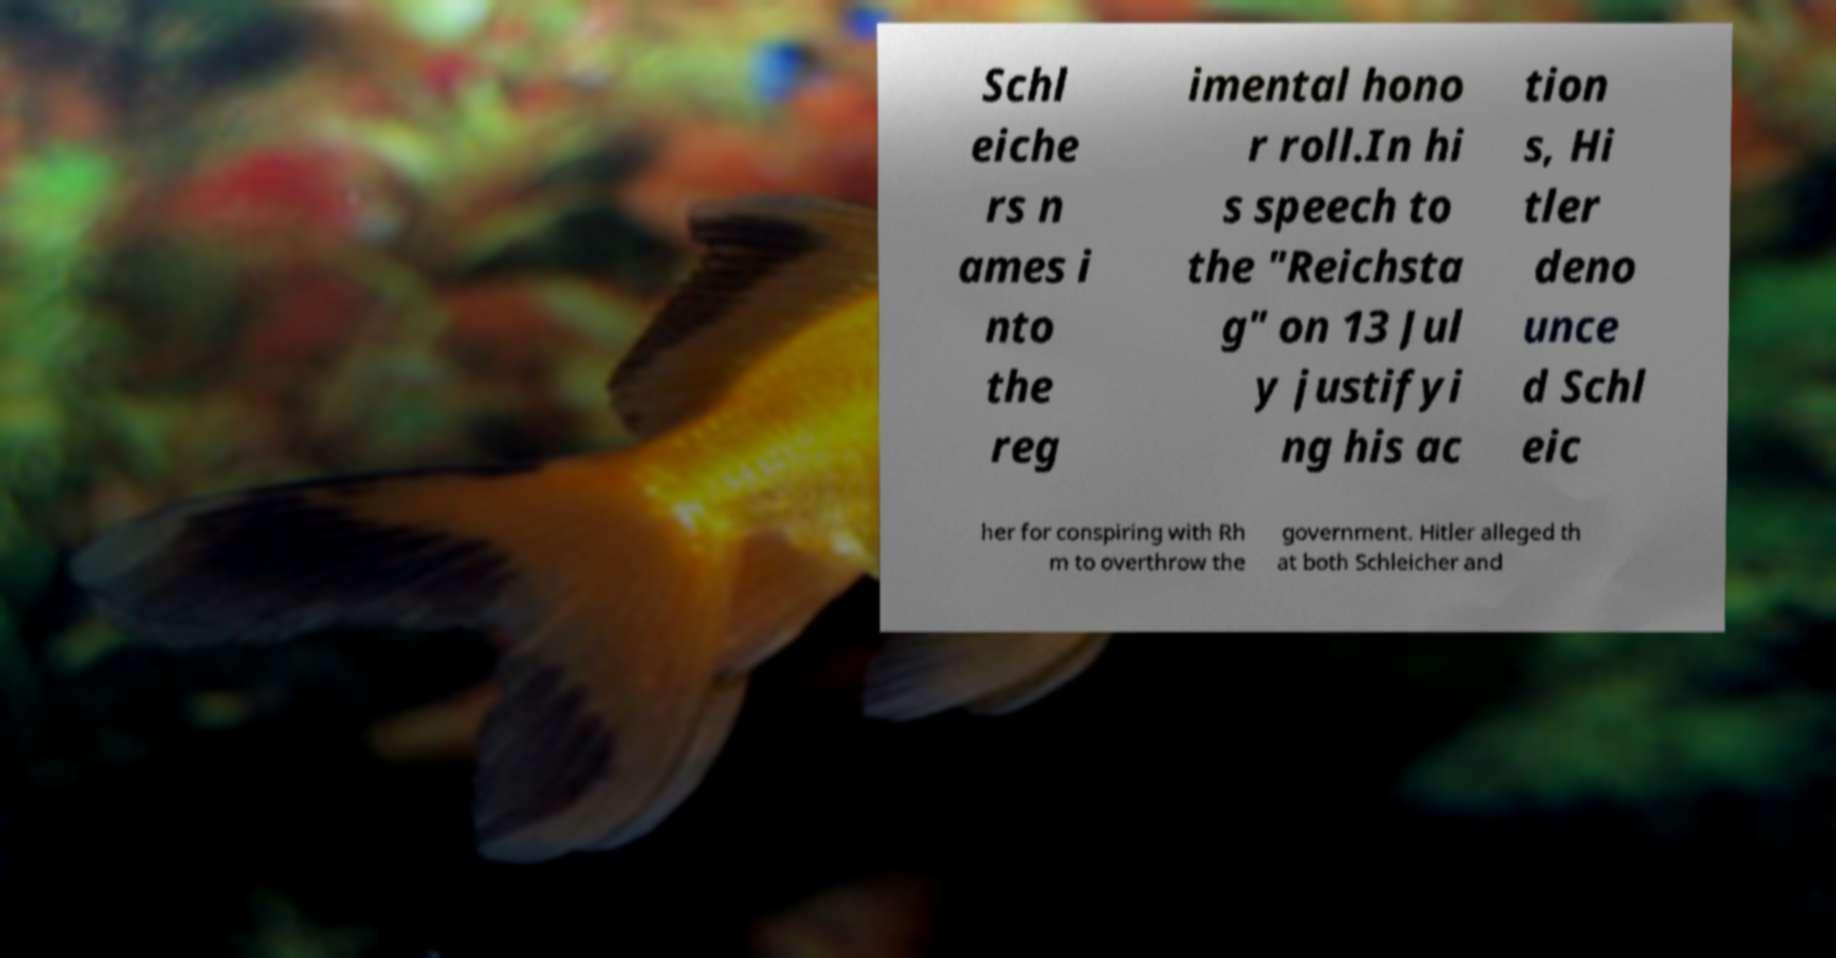I need the written content from this picture converted into text. Can you do that? Schl eiche rs n ames i nto the reg imental hono r roll.In hi s speech to the "Reichsta g" on 13 Jul y justifyi ng his ac tion s, Hi tler deno unce d Schl eic her for conspiring with Rh m to overthrow the government. Hitler alleged th at both Schleicher and 